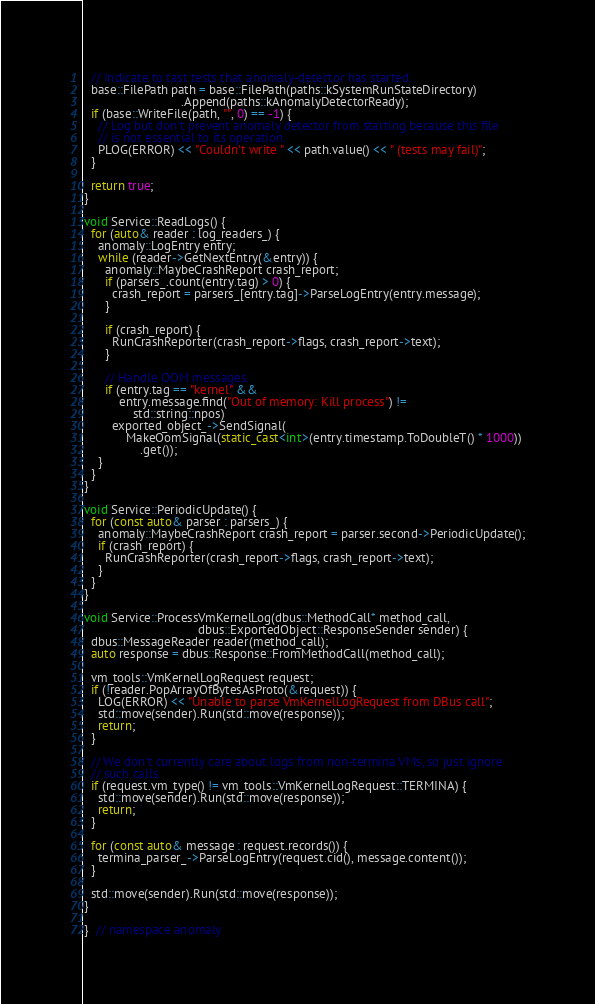Convert code to text. <code><loc_0><loc_0><loc_500><loc_500><_C++_>
  // Indicate to tast tests that anomaly-detector has started.
  base::FilePath path = base::FilePath(paths::kSystemRunStateDirectory)
                            .Append(paths::kAnomalyDetectorReady);
  if (base::WriteFile(path, "", 0) == -1) {
    // Log but don't prevent anomaly detector from starting because this file
    // is not essential to its operation.
    PLOG(ERROR) << "Couldn't write " << path.value() << " (tests may fail)";
  }

  return true;
}

void Service::ReadLogs() {
  for (auto& reader : log_readers_) {
    anomaly::LogEntry entry;
    while (reader->GetNextEntry(&entry)) {
      anomaly::MaybeCrashReport crash_report;
      if (parsers_.count(entry.tag) > 0) {
        crash_report = parsers_[entry.tag]->ParseLogEntry(entry.message);
      }

      if (crash_report) {
        RunCrashReporter(crash_report->flags, crash_report->text);
      }

      // Handle OOM messages.
      if (entry.tag == "kernel" &&
          entry.message.find("Out of memory: Kill process") !=
              std::string::npos)
        exported_object_->SendSignal(
            MakeOomSignal(static_cast<int>(entry.timestamp.ToDoubleT() * 1000))
                .get());
    }
  }
}

void Service::PeriodicUpdate() {
  for (const auto& parser : parsers_) {
    anomaly::MaybeCrashReport crash_report = parser.second->PeriodicUpdate();
    if (crash_report) {
      RunCrashReporter(crash_report->flags, crash_report->text);
    }
  }
}

void Service::ProcessVmKernelLog(dbus::MethodCall* method_call,
                                 dbus::ExportedObject::ResponseSender sender) {
  dbus::MessageReader reader(method_call);
  auto response = dbus::Response::FromMethodCall(method_call);

  vm_tools::VmKernelLogRequest request;
  if (!reader.PopArrayOfBytesAsProto(&request)) {
    LOG(ERROR) << "Unable to parse VmKernelLogRequest from DBus call";
    std::move(sender).Run(std::move(response));
    return;
  }

  // We don't currently care about logs from non-termina VMs, so just ignore
  // such calls.
  if (request.vm_type() != vm_tools::VmKernelLogRequest::TERMINA) {
    std::move(sender).Run(std::move(response));
    return;
  }

  for (const auto& message : request.records()) {
    termina_parser_->ParseLogEntry(request.cid(), message.content());
  }

  std::move(sender).Run(std::move(response));
}

}  // namespace anomaly
</code> 